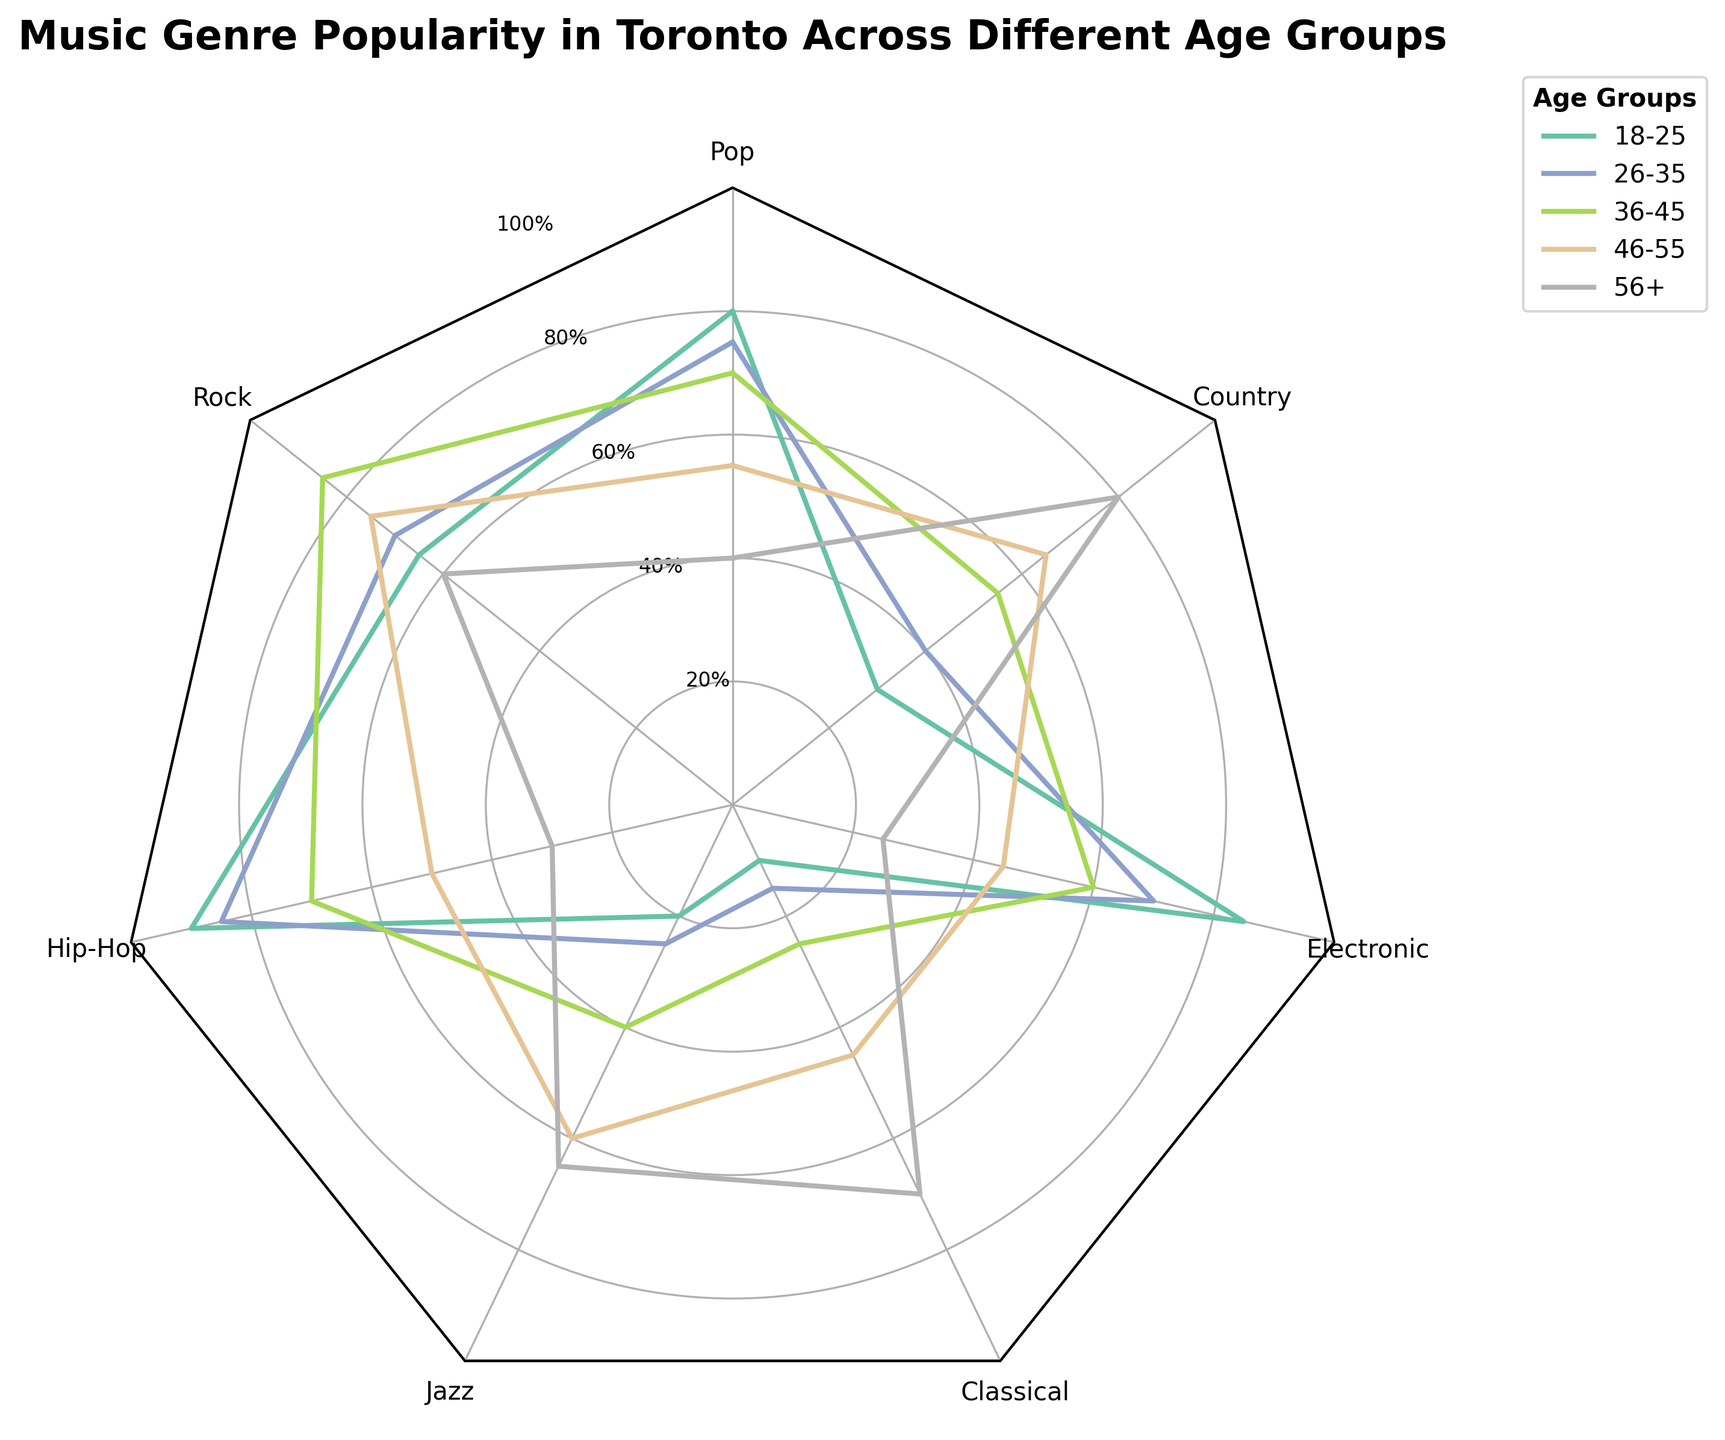What's the most popular music genre among the age group 18-25? The most popular genre for 18-25 year-olds is identified by finding the highest percentage value for this age group on the radar chart. The highest value is Hip-Hop at 90%.
Answer: Hip-Hop Which age group has the lowest preference for Jazz? To find the answer, identify the Jazz data points across all age groups and compare them. The 18-25 age group has the lowest preference for Jazz at 20%.
Answer: 18-25 What is the average popularity of Pop music across all age groups? Calculate the sum of the Pop music preferences across all age groups (80 + 75 + 70 + 55 + 40 = 320). Then divide by the number of age groups (320 / 5 = 64).
Answer: 64 Between Rock and Classical, which genre sees a higher increase in popularity from age group 18-25 to age group 56+? Compare the percentage increase for both genres from 18-25 to 56+. For Rock (60 - 65 = -5) and for Classical (70 - 10 = 60). Classical has the higher increase of 60%.
Answer: Classical What’s the least popular genre in the 26-35 age group? Identify the smallest value among the data points for the 26-35 age group. Classical is the least popular at 15%.
Answer: Classical Which age group has the highest overall preference for Hip-Hop music? To find the highest overall preference, look for the maximum Hip-Hop value across all age groups. The 18-25 age group has the highest preference at 90%.
Answer: 18-25 Which two genres have the closest popularity values for the 36-45 age group? Compare the values for each genre in the 36-45 age group to find the closest pair: Pop (70), Rock (85), Hip-Hop (70), Jazz (40), Classical (25), Electronic (60), Country (55). Pop and Hip-Hop both have values of 70.
Answer: Pop and Hip-Hop What is the difference in popularity of Country music between the age groups 26-35 and 56+? Subtract the Country music value for the 26-35 age group from the value for the 56+ age group: 80 - 40 = 40.
Answer: 40 Which genre is the most consistently popular across all age groups? Calculate the variance in the popularity values of each genre across all age groups. The genre with the lowest variance is Country (30, 40, 55, 65, 80).
Answer: Country 